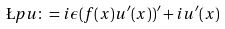<formula> <loc_0><loc_0><loc_500><loc_500>\L p u \colon = i \epsilon ( f ( x ) u ^ { \prime } ( x ) ) ^ { \prime } + i u ^ { \prime } ( x )</formula> 